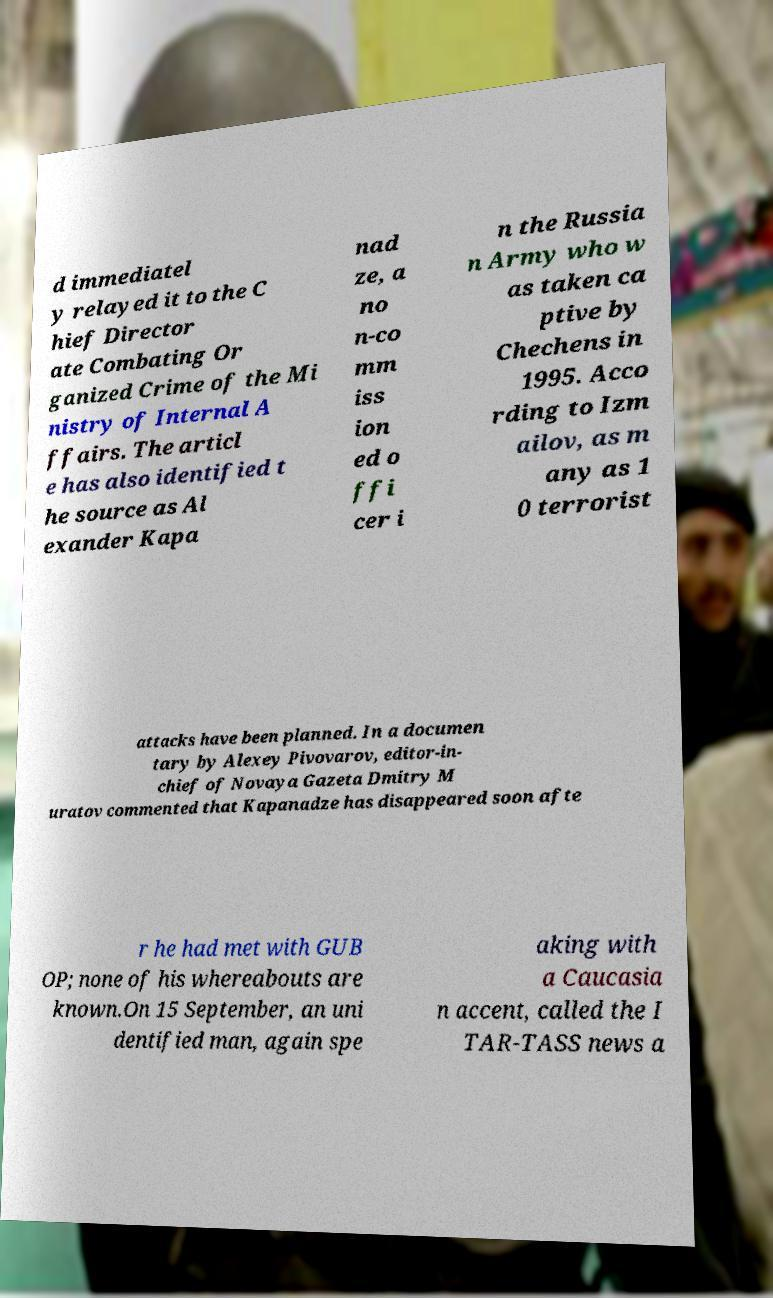Please read and relay the text visible in this image. What does it say? d immediatel y relayed it to the C hief Director ate Combating Or ganized Crime of the Mi nistry of Internal A ffairs. The articl e has also identified t he source as Al exander Kapa nad ze, a no n-co mm iss ion ed o ffi cer i n the Russia n Army who w as taken ca ptive by Chechens in 1995. Acco rding to Izm ailov, as m any as 1 0 terrorist attacks have been planned. In a documen tary by Alexey Pivovarov, editor-in- chief of Novaya Gazeta Dmitry M uratov commented that Kapanadze has disappeared soon afte r he had met with GUB OP; none of his whereabouts are known.On 15 September, an uni dentified man, again spe aking with a Caucasia n accent, called the I TAR-TASS news a 